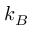<formula> <loc_0><loc_0><loc_500><loc_500>k _ { B }</formula> 